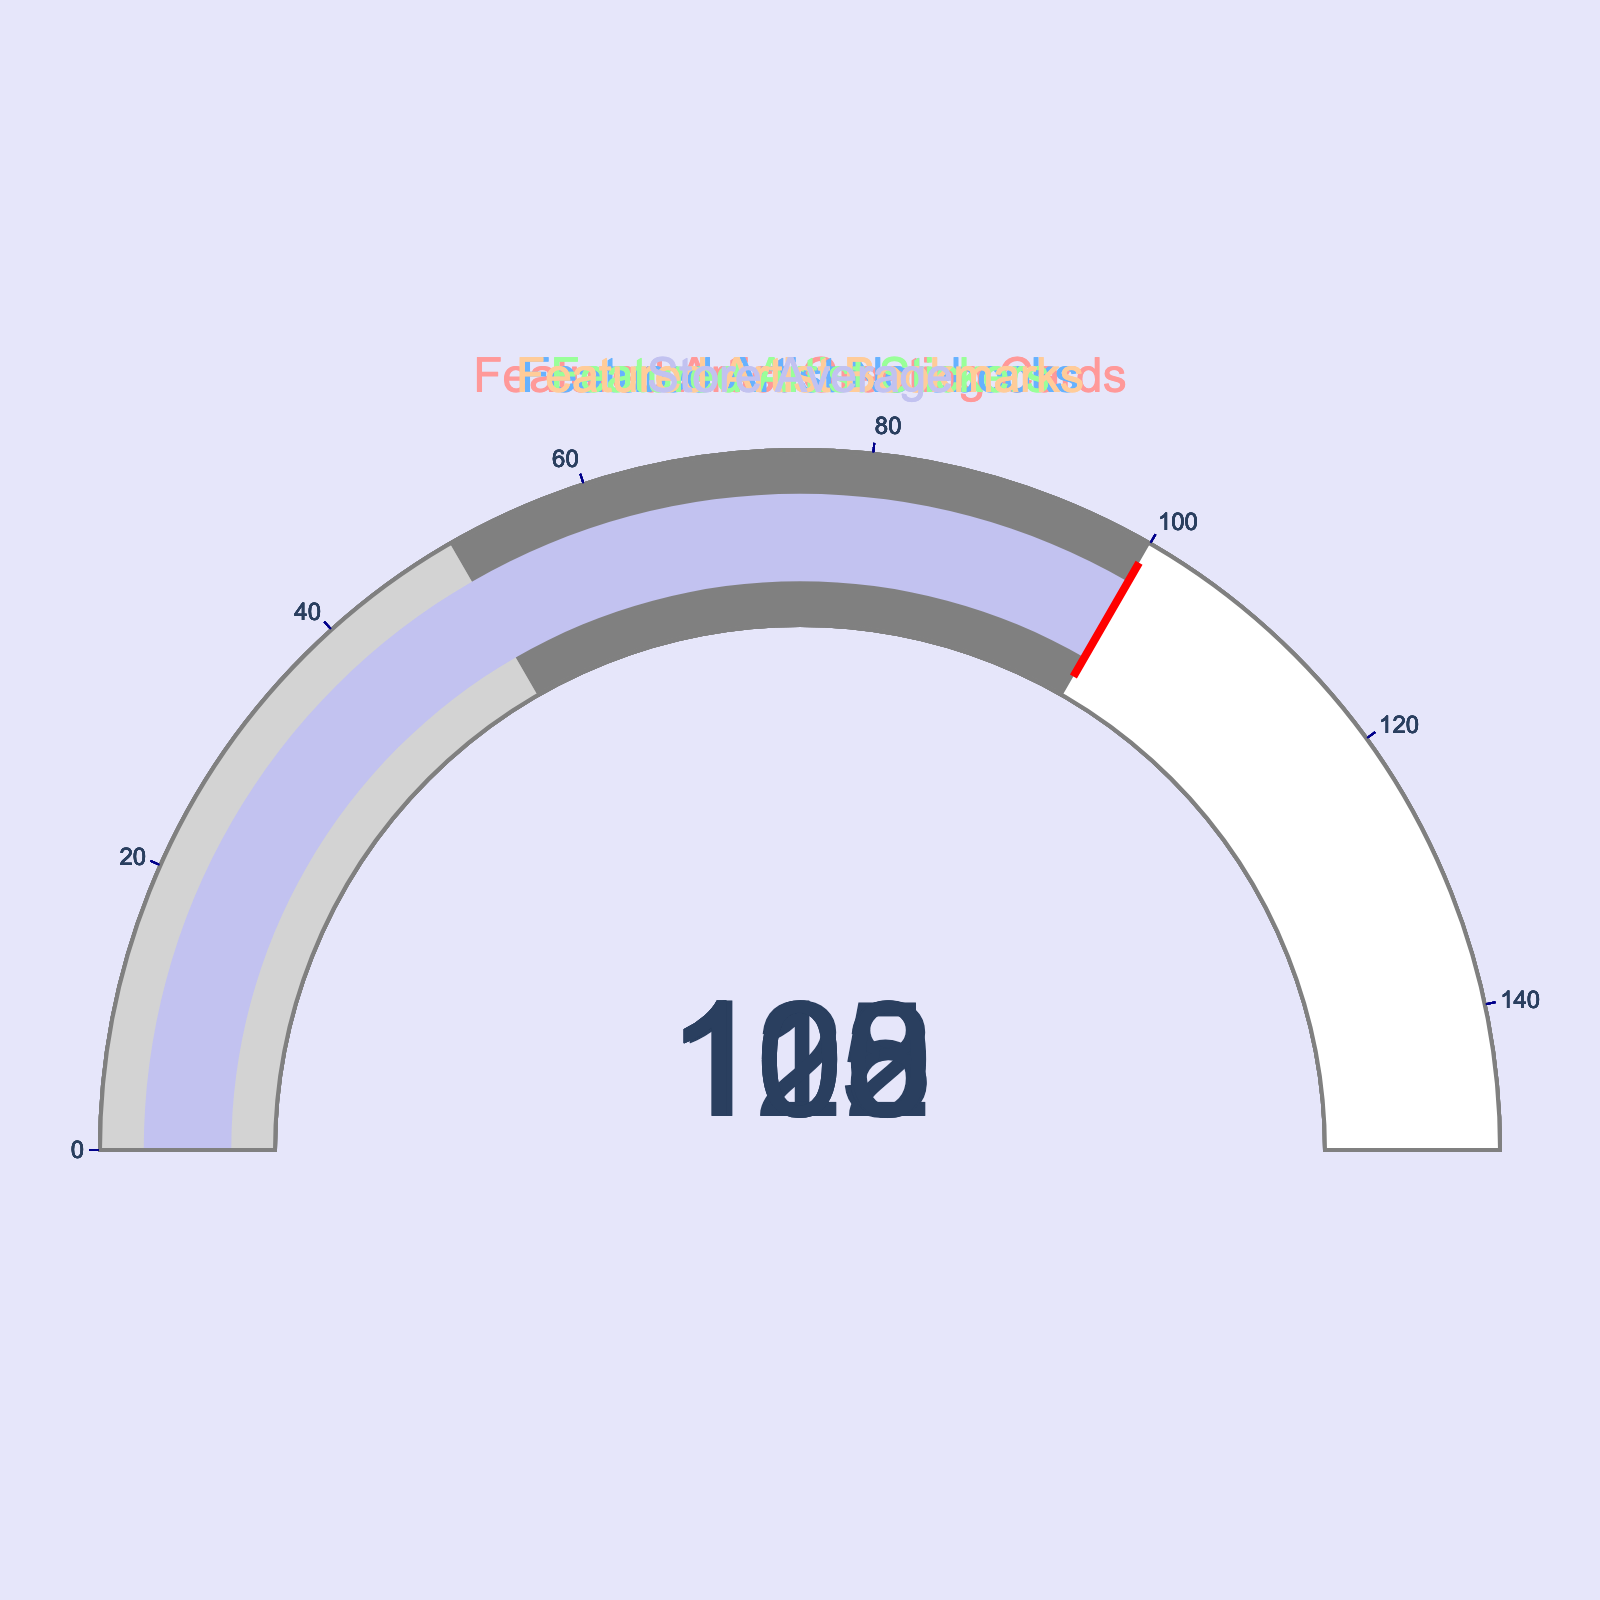How many data points are displayed in the figure? There are 5 categories listed in the data: Featured Artist Greeting Cards, Featured Artist Notebooks, Featured Artist Stickers, Featured Artist Bookmarks, and Store Average. Each category is represented by one gauge.
Answer: 5 Which category has the highest sales performance? Among the sales performance percentages, the highest value is 122% which corresponds to the Featured Artist Stickers.
Answer: Featured Artist Stickers Which category has the lowest sales performance among the featured artist items? By comparing the sales performances of the featured artist items: Greeting Cards (115%), Notebooks (108%), Stickers (122%), and Bookmarks (103%), the lowest value is 103% which corresponds to the Featured Artist Bookmarks.
Answer: Featured Artist Bookmarks How much higher is the sales performance of Featured Artist Greeting Cards compared to the Store Average? The sales performance of Featured Artist Greeting Cards is 115%, and the Store Average is 100%. The difference can be calculated as 115% - 100% = 15%.
Answer: 15% Compare the sales performance of Featured Artist Notebooks and Featured Artist Stickers. Which one is greater and by how much? The sales performance of Featured Artist Notebooks is 108%, and for Featured Artist Stickers, it is 122%. The difference is 122% - 108% = 14%, with Sticker having the higher performance.
Answer: Stickers by 14% Which categories have exceeded the sales performance of the Store Average by more than 10%? The Store Average is 100%. To exceed by more than 10%, a category must have a performance greater than 110%. The categories with sales performance greater than 110% are Featured Artist Greeting Cards (115%) and Featured Artist Stickers (122%).
Answer: Featured Artist Greeting Cards and Stickers What is the average sales performance of all the featured artist items? To find the average, sum the sales performance percentages of the featured artist items and divide by their count. The values are: 115 (Greeting Cards), 108 (Notebooks), 122 (Stickers), and 103 (Bookmarks). The sum is 115 + 108 + 122 + 103 = 448. The average is 448 / 4 = 112%.
Answer: 112% What is the range of the sales performance percentages for the featured artist items? The range is calculated by subtracting the lowest value from the highest value among the percentages. The highest value is 122% (Stickers), and the lowest is 103% (Bookmarks). The range is 122% - 103% = 19%.
Answer: 19% 